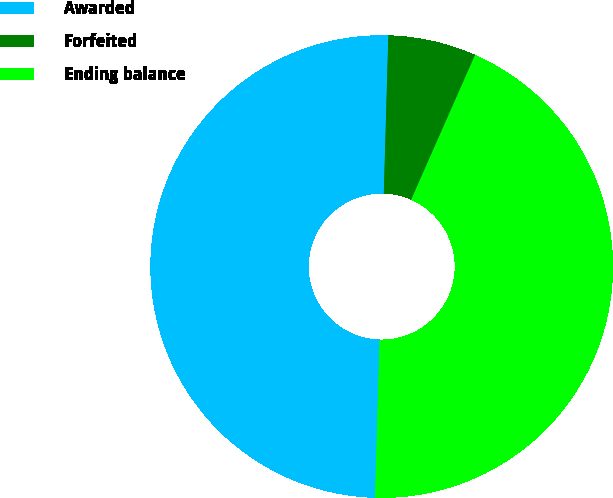Convert chart to OTSL. <chart><loc_0><loc_0><loc_500><loc_500><pie_chart><fcel>Awarded<fcel>Forfeited<fcel>Ending balance<nl><fcel>50.0%<fcel>6.16%<fcel>43.84%<nl></chart> 